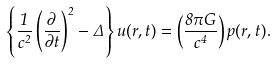<formula> <loc_0><loc_0><loc_500><loc_500>\left \{ \frac { 1 } { c ^ { 2 } } \left ( \frac { \partial } { \partial t } \right ) ^ { 2 } - \Delta \right \} { u } ( { r } , t ) = \left ( \frac { 8 \pi G } { c ^ { 4 } } \right ) { p } ( { r } , t ) .</formula> 